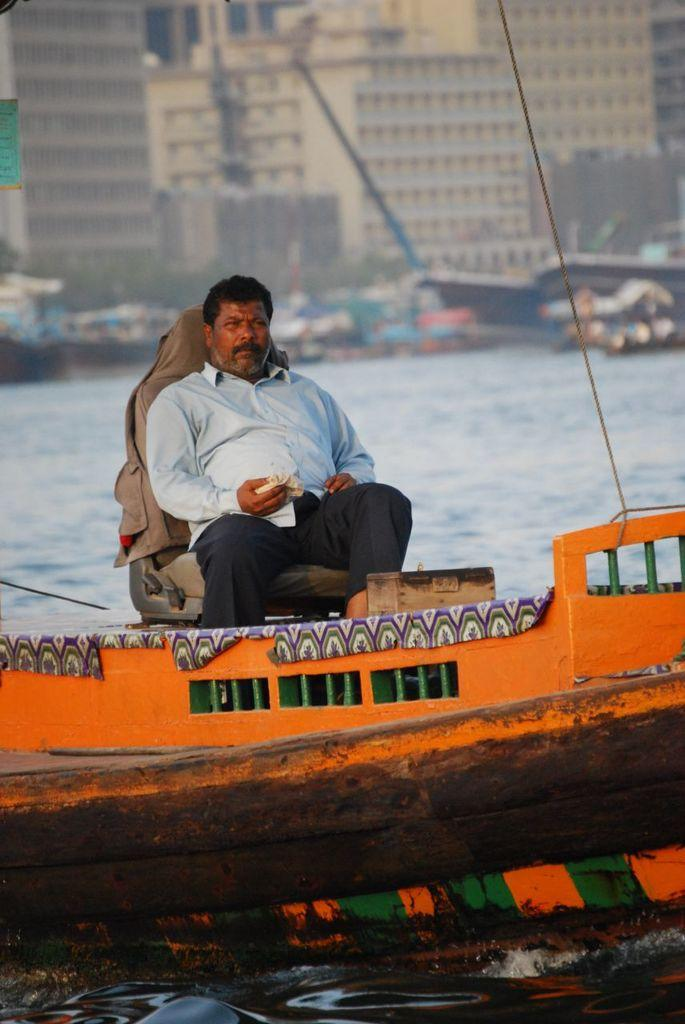What is the person in the image doing? The person is sitting on a boat. Where is the boat located? The boat is on a river. What can be seen in the background of the image? There are buildings visible in the background. Are there any other boats in the image? Yes, there are other boats behind the person. How is the background of the image depicted? The background is blurred. What type of banana is the person holding in the image? There is no banana present in the image. How does the person's haircut look in the image? There is no information about the person's haircut in the image. 